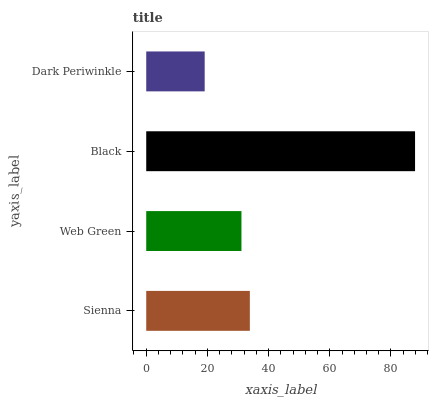Is Dark Periwinkle the minimum?
Answer yes or no. Yes. Is Black the maximum?
Answer yes or no. Yes. Is Web Green the minimum?
Answer yes or no. No. Is Web Green the maximum?
Answer yes or no. No. Is Sienna greater than Web Green?
Answer yes or no. Yes. Is Web Green less than Sienna?
Answer yes or no. Yes. Is Web Green greater than Sienna?
Answer yes or no. No. Is Sienna less than Web Green?
Answer yes or no. No. Is Sienna the high median?
Answer yes or no. Yes. Is Web Green the low median?
Answer yes or no. Yes. Is Black the high median?
Answer yes or no. No. Is Sienna the low median?
Answer yes or no. No. 